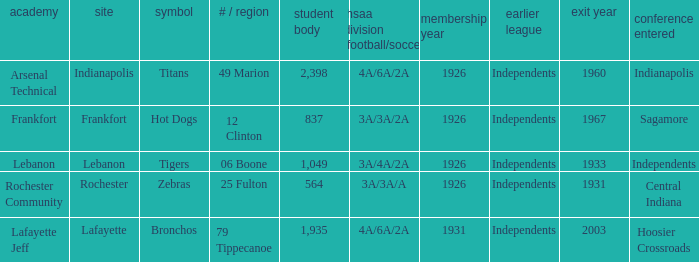What is the average enrollment that has hot dogs as the mascot, with a year joined later than 1926? None. 